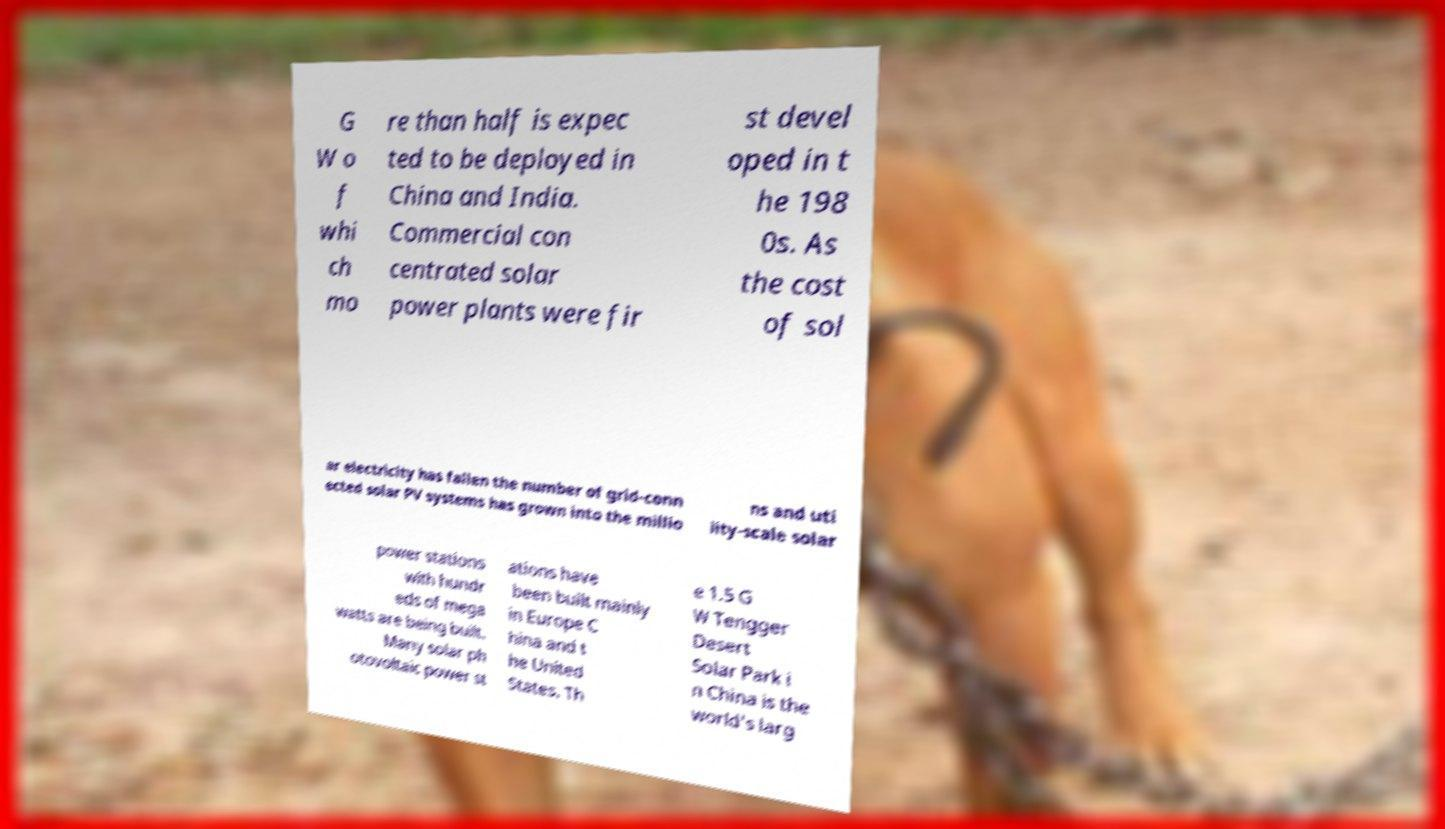Could you extract and type out the text from this image? G W o f whi ch mo re than half is expec ted to be deployed in China and India. Commercial con centrated solar power plants were fir st devel oped in t he 198 0s. As the cost of sol ar electricity has fallen the number of grid-conn ected solar PV systems has grown into the millio ns and uti lity-scale solar power stations with hundr eds of mega watts are being built. Many solar ph otovoltaic power st ations have been built mainly in Europe C hina and t he United States. Th e 1.5 G W Tengger Desert Solar Park i n China is the world's larg 